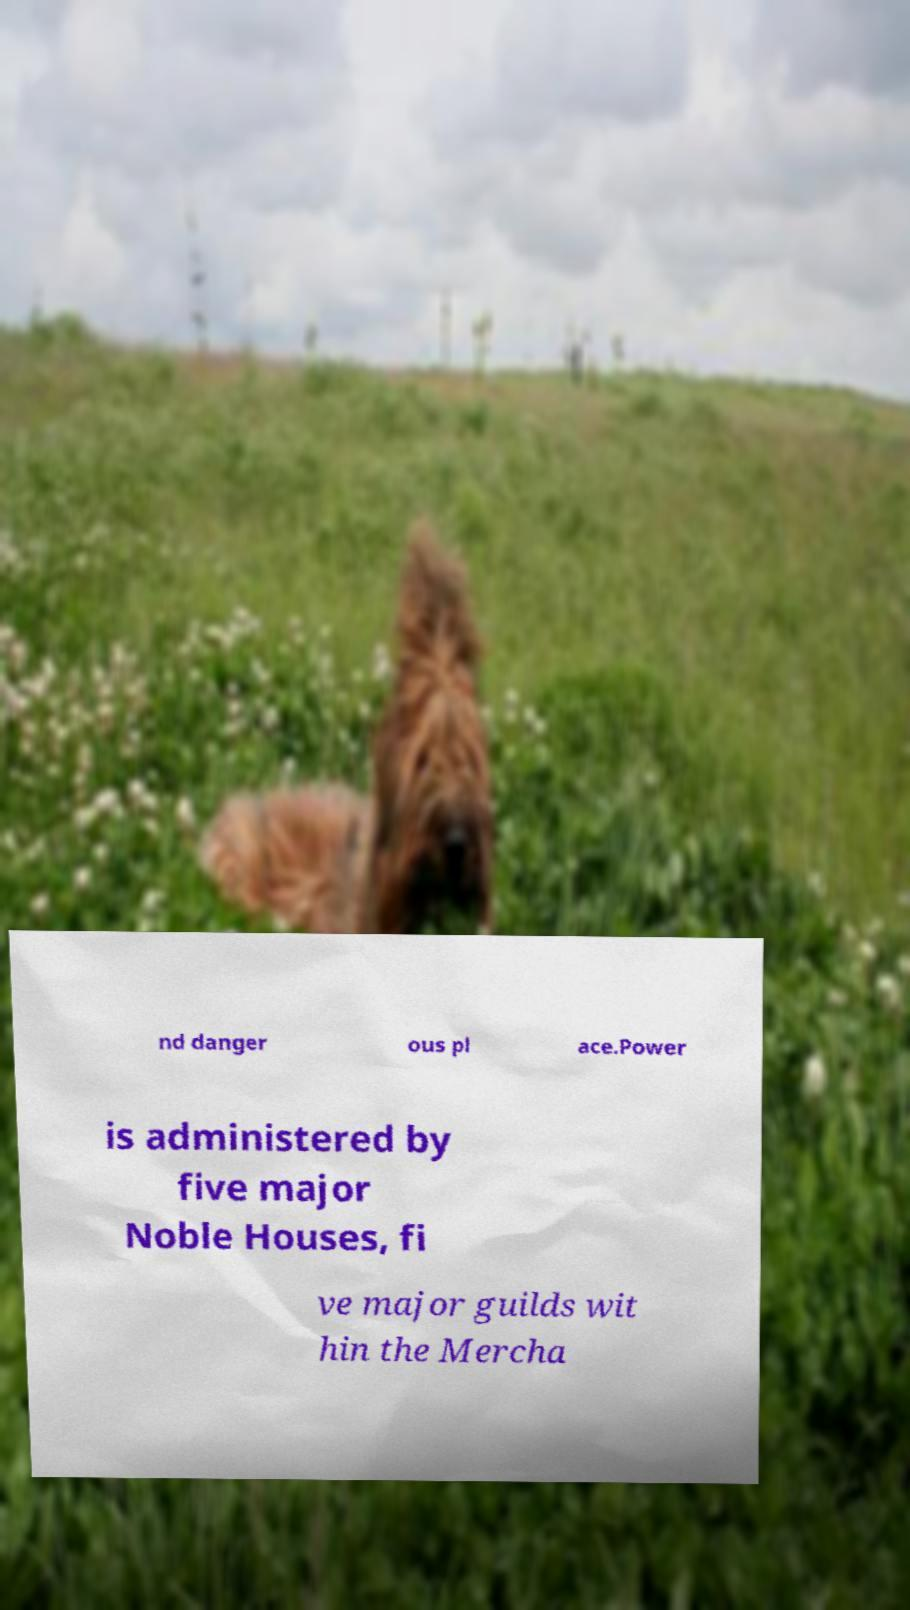There's text embedded in this image that I need extracted. Can you transcribe it verbatim? nd danger ous pl ace.Power is administered by five major Noble Houses, fi ve major guilds wit hin the Mercha 